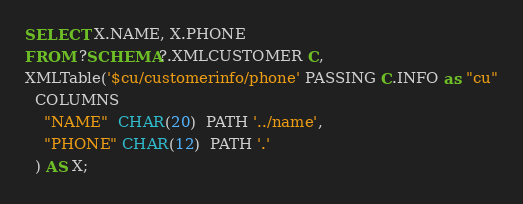<code> <loc_0><loc_0><loc_500><loc_500><_SQL_>SELECT X.NAME, X.PHONE
FROM ?SCHEMA?.XMLCUSTOMER C,
XMLTable('$cu/customerinfo/phone' PASSING C.INFO as "cu"
  COLUMNS 
    "NAME"  CHAR(20)  PATH '../name',
    "PHONE" CHAR(12)  PATH '.'
  ) AS X;
</code> 